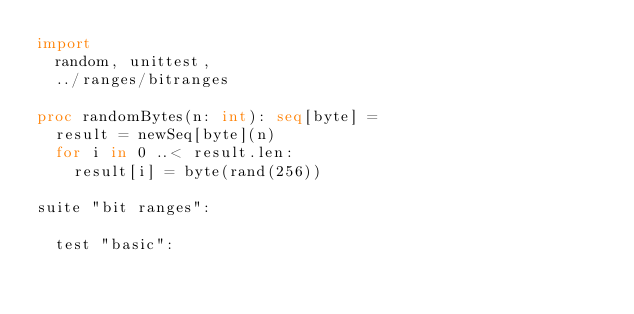<code> <loc_0><loc_0><loc_500><loc_500><_Nim_>import
  random, unittest,
  ../ranges/bitranges

proc randomBytes(n: int): seq[byte] =
  result = newSeq[byte](n)
  for i in 0 ..< result.len:
    result[i] = byte(rand(256))

suite "bit ranges":

  test "basic":</code> 